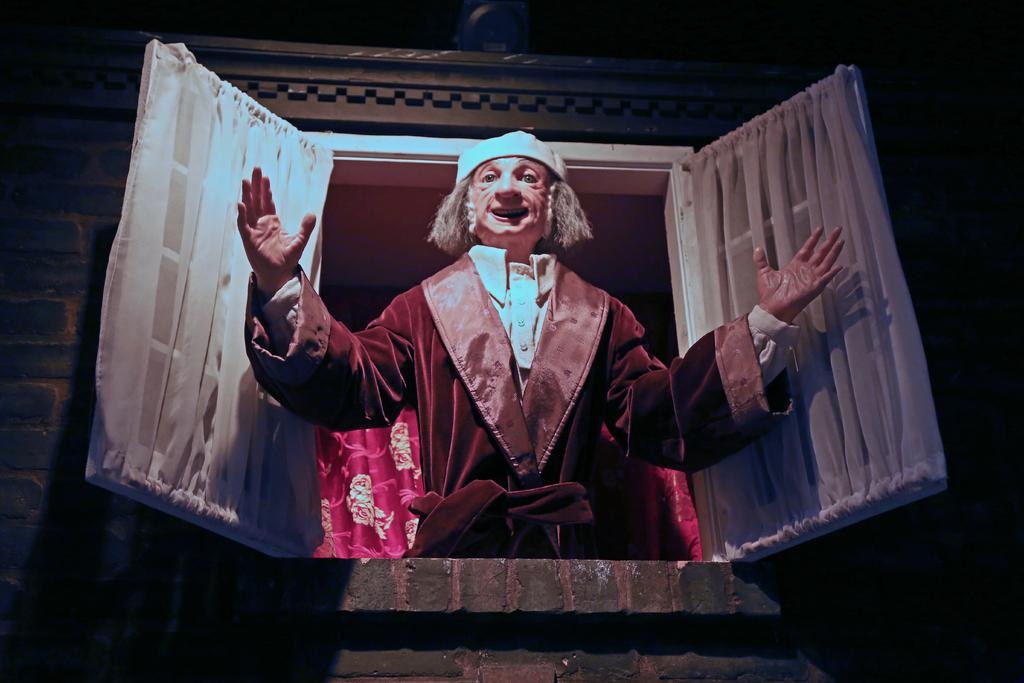What is the main subject of the image? There is a person in the image. Can you describe the setting of the image? The image appears to be a window. What type of shoes is the person wearing in the image? There is no information about shoes in the image, as it only shows a person and a window. 